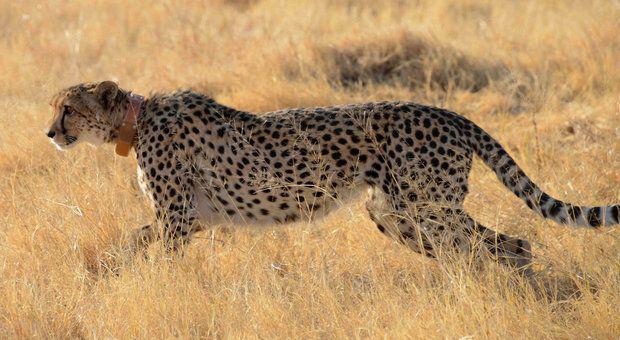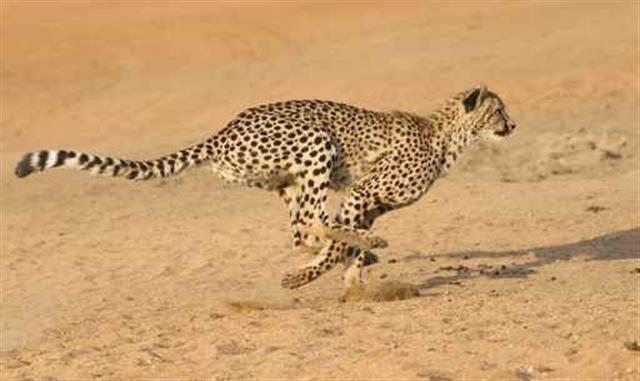The first image is the image on the left, the second image is the image on the right. Examine the images to the left and right. Is the description "An image contains a cheetah facing towards the left." accurate? Answer yes or no. Yes. 